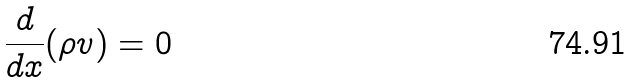Convert formula to latex. <formula><loc_0><loc_0><loc_500><loc_500>\frac { d } { d x } ( \rho v ) = 0</formula> 